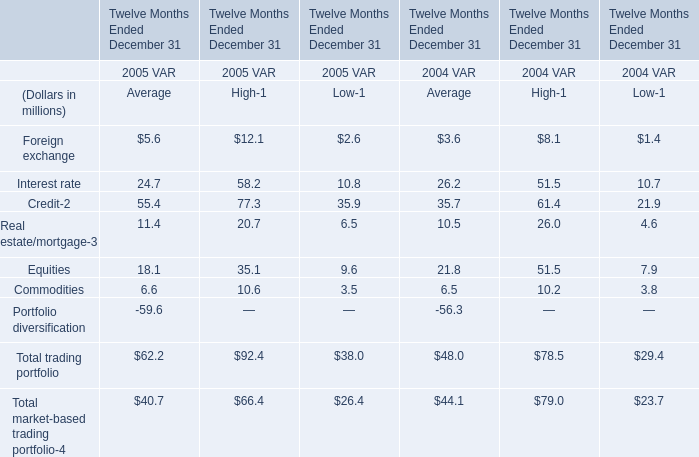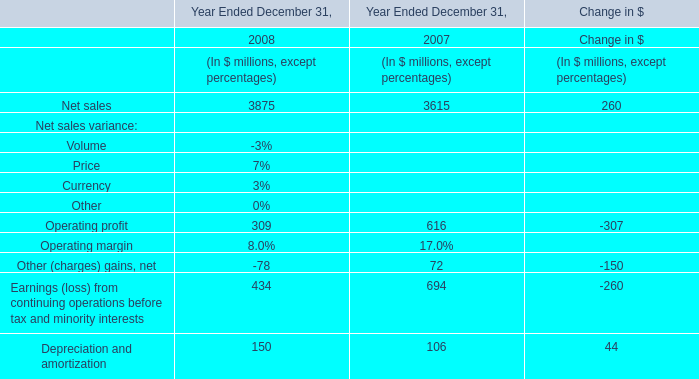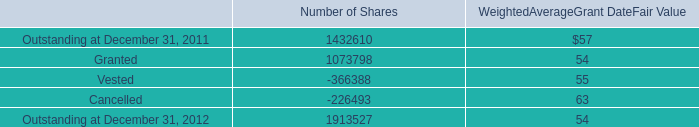What will Foreign exchange be like in 2006 if it continues to grow at the same rate as it did in 2005? (in million) 
Computations: (5.6 + ((5.6 * (5.6 - 3.6)) / 3.6))
Answer: 8.71111. 